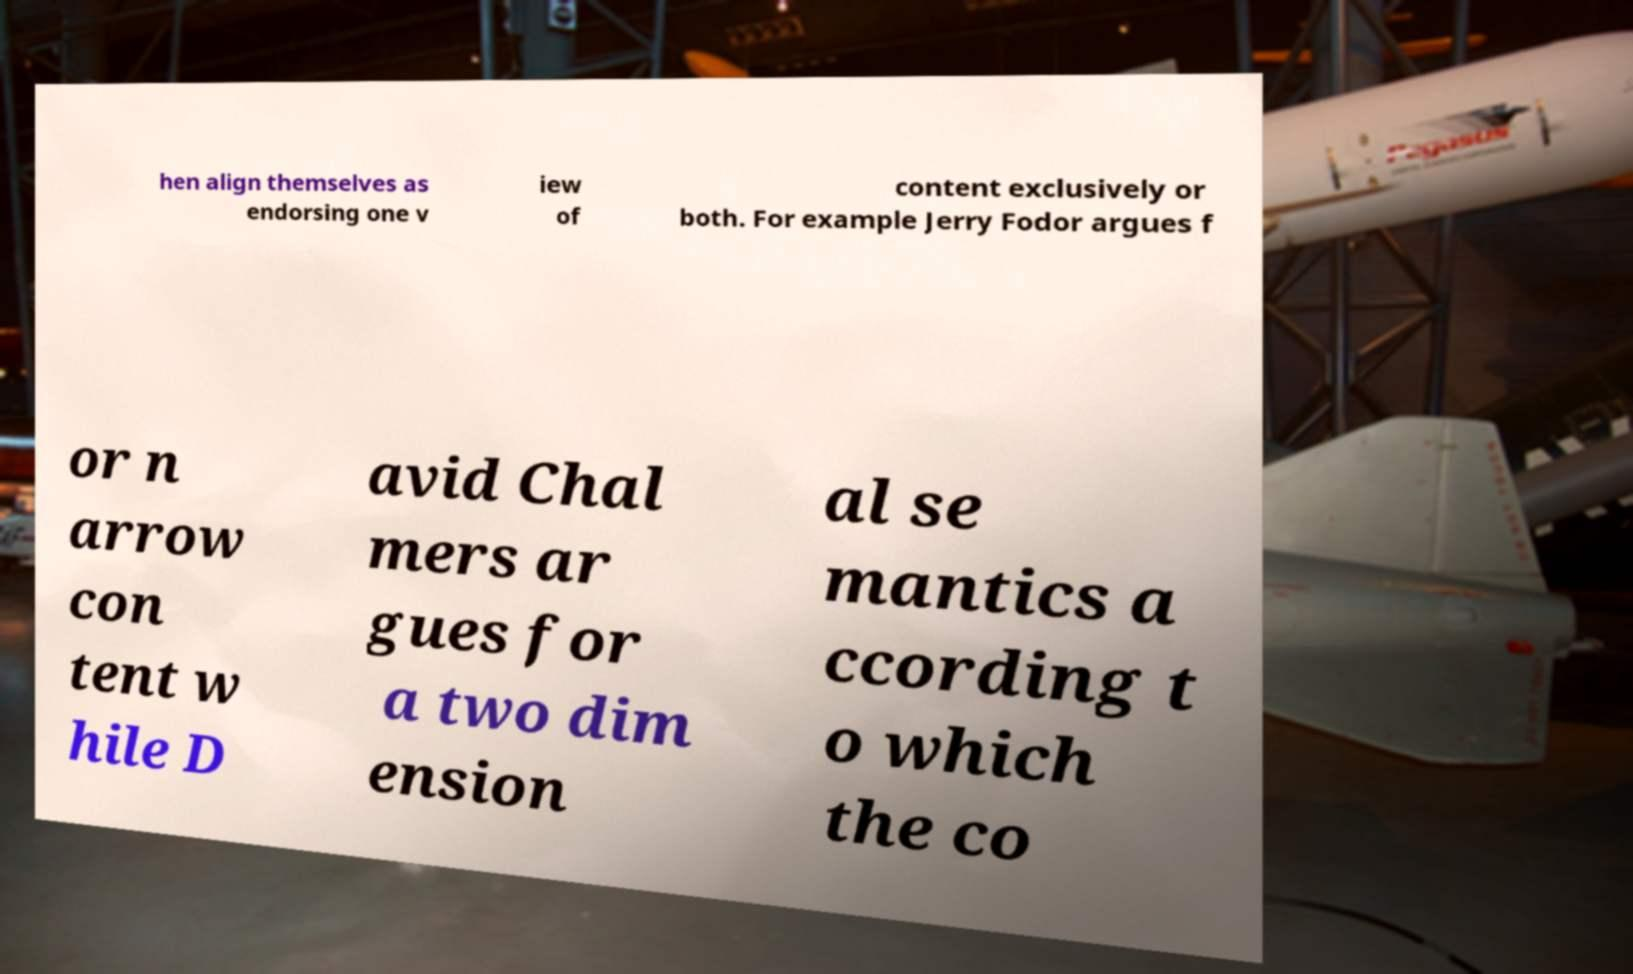Could you extract and type out the text from this image? hen align themselves as endorsing one v iew of content exclusively or both. For example Jerry Fodor argues f or n arrow con tent w hile D avid Chal mers ar gues for a two dim ension al se mantics a ccording t o which the co 